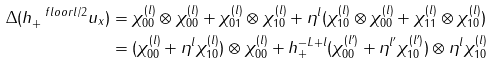<formula> <loc_0><loc_0><loc_500><loc_500>\Delta ( h _ { + } ^ { \ f l o o r { l / 2 } } u _ { x } ) & = \chi _ { 0 0 } ^ { ( l ) } \otimes \chi _ { 0 0 } ^ { ( l ) } + \chi _ { 0 1 } ^ { ( l ) } \otimes \chi _ { 1 0 } ^ { ( l ) } + \eta ^ { l } ( \chi _ { 1 0 } ^ { ( l ) } \otimes \chi _ { 0 0 } ^ { ( l ) } + \chi _ { 1 1 } ^ { ( l ) } \otimes \chi _ { 1 0 } ^ { ( l ) } ) \\ & = ( \chi _ { 0 0 } ^ { ( l ) } + \eta ^ { l } \chi _ { 1 0 } ^ { ( l ) } ) \otimes \chi _ { 0 0 } ^ { ( l ) } + h _ { + } ^ { - L + l } ( \chi _ { 0 0 } ^ { ( l ^ { \prime } ) } + \eta ^ { l ^ { \prime } } \chi _ { 1 0 } ^ { ( l ^ { \prime } ) } ) \otimes \eta ^ { l } \chi _ { 1 0 } ^ { ( l ) }</formula> 